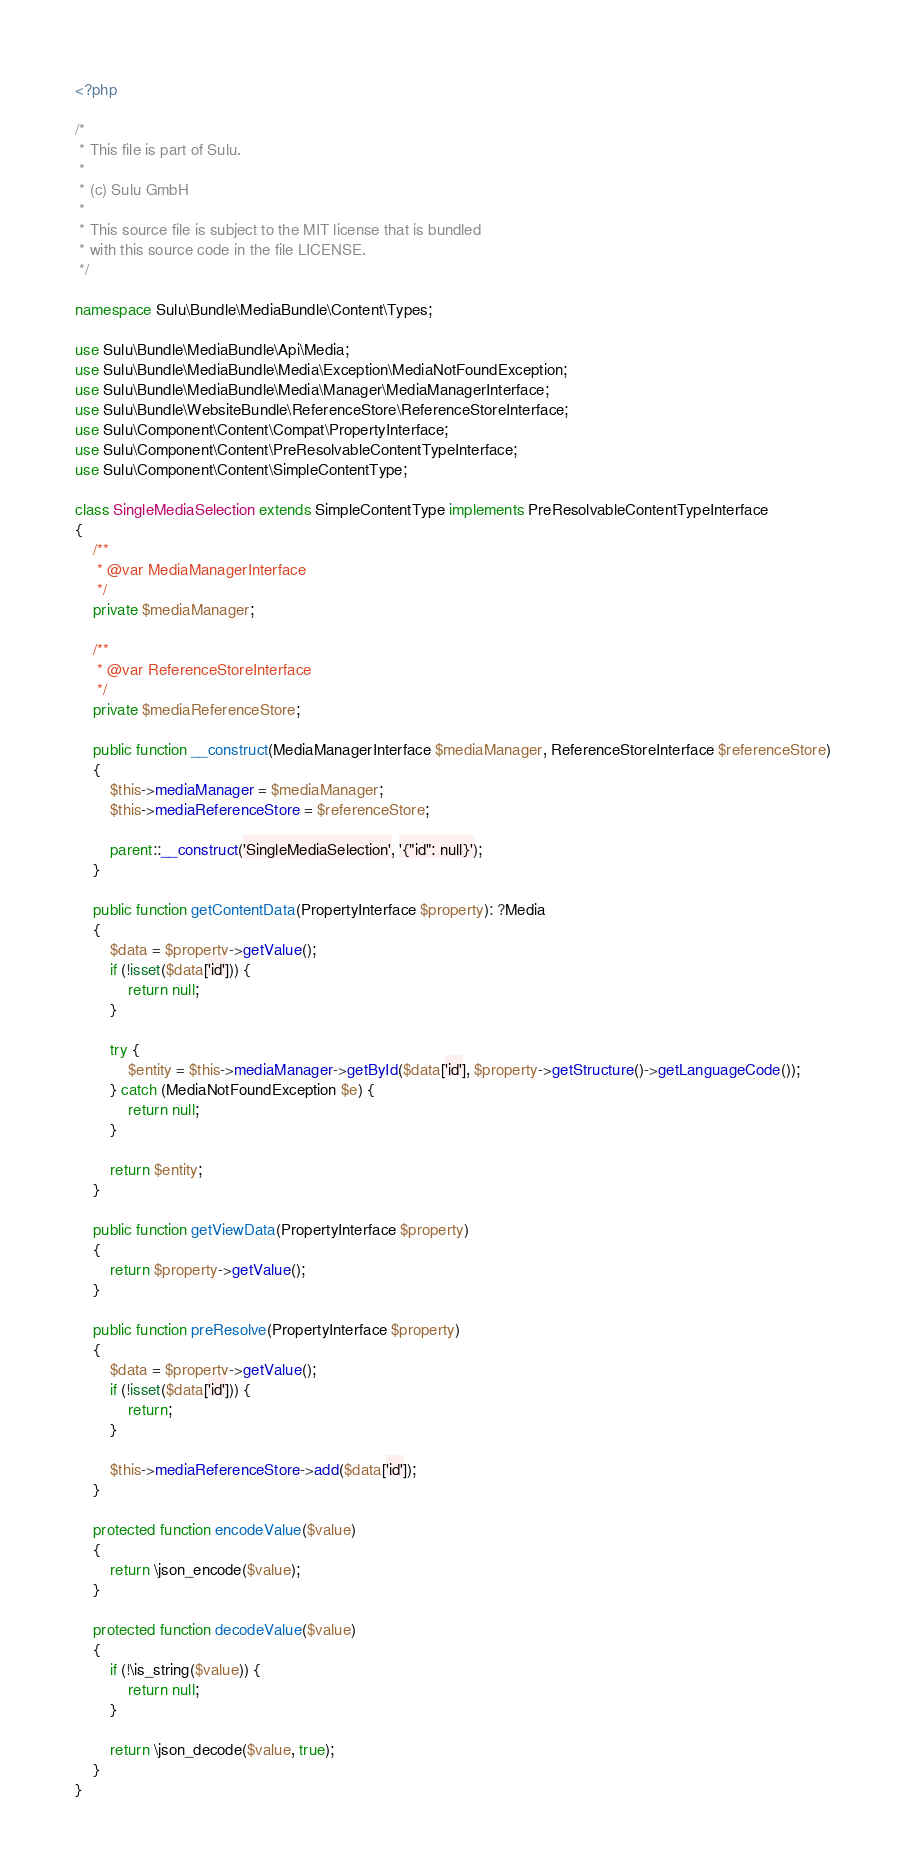Convert code to text. <code><loc_0><loc_0><loc_500><loc_500><_PHP_><?php

/*
 * This file is part of Sulu.
 *
 * (c) Sulu GmbH
 *
 * This source file is subject to the MIT license that is bundled
 * with this source code in the file LICENSE.
 */

namespace Sulu\Bundle\MediaBundle\Content\Types;

use Sulu\Bundle\MediaBundle\Api\Media;
use Sulu\Bundle\MediaBundle\Media\Exception\MediaNotFoundException;
use Sulu\Bundle\MediaBundle\Media\Manager\MediaManagerInterface;
use Sulu\Bundle\WebsiteBundle\ReferenceStore\ReferenceStoreInterface;
use Sulu\Component\Content\Compat\PropertyInterface;
use Sulu\Component\Content\PreResolvableContentTypeInterface;
use Sulu\Component\Content\SimpleContentType;

class SingleMediaSelection extends SimpleContentType implements PreResolvableContentTypeInterface
{
    /**
     * @var MediaManagerInterface
     */
    private $mediaManager;

    /**
     * @var ReferenceStoreInterface
     */
    private $mediaReferenceStore;

    public function __construct(MediaManagerInterface $mediaManager, ReferenceStoreInterface $referenceStore)
    {
        $this->mediaManager = $mediaManager;
        $this->mediaReferenceStore = $referenceStore;

        parent::__construct('SingleMediaSelection', '{"id": null}');
    }

    public function getContentData(PropertyInterface $property): ?Media
    {
        $data = $property->getValue();
        if (!isset($data['id'])) {
            return null;
        }

        try {
            $entity = $this->mediaManager->getById($data['id'], $property->getStructure()->getLanguageCode());
        } catch (MediaNotFoundException $e) {
            return null;
        }

        return $entity;
    }

    public function getViewData(PropertyInterface $property)
    {
        return $property->getValue();
    }

    public function preResolve(PropertyInterface $property)
    {
        $data = $property->getValue();
        if (!isset($data['id'])) {
            return;
        }

        $this->mediaReferenceStore->add($data['id']);
    }

    protected function encodeValue($value)
    {
        return \json_encode($value);
    }

    protected function decodeValue($value)
    {
        if (!\is_string($value)) {
            return null;
        }

        return \json_decode($value, true);
    }
}
</code> 